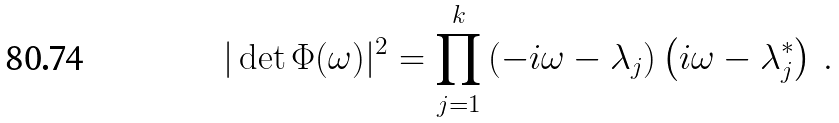Convert formula to latex. <formula><loc_0><loc_0><loc_500><loc_500>| \det \Phi ( \omega ) | ^ { 2 } = \prod ^ { k } _ { j = 1 } \left ( - i \omega - \lambda _ { j } \right ) \left ( i \omega - \lambda ^ { * } _ { j } \right ) \, .</formula> 